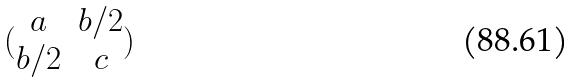<formula> <loc_0><loc_0><loc_500><loc_500>( \begin{matrix} a & b / 2 \\ b / 2 & c \end{matrix} )</formula> 